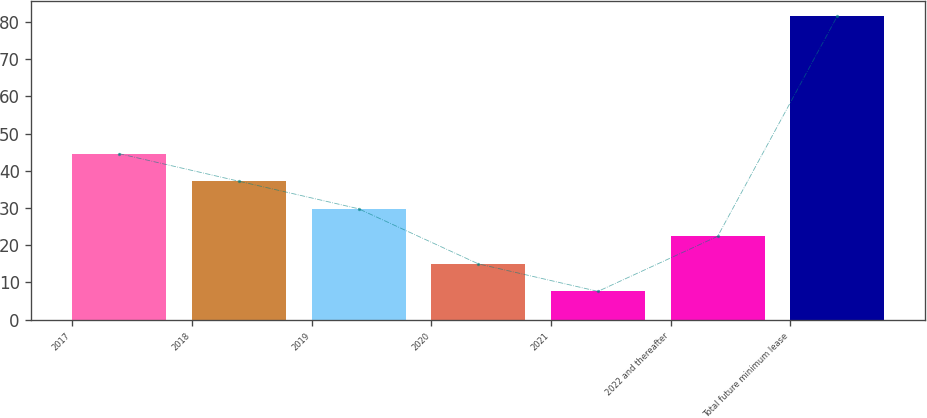<chart> <loc_0><loc_0><loc_500><loc_500><bar_chart><fcel>2017<fcel>2018<fcel>2019<fcel>2020<fcel>2021<fcel>2022 and thereafter<fcel>Total future minimum lease<nl><fcel>44.6<fcel>37.2<fcel>29.8<fcel>15<fcel>7.6<fcel>22.4<fcel>81.6<nl></chart> 